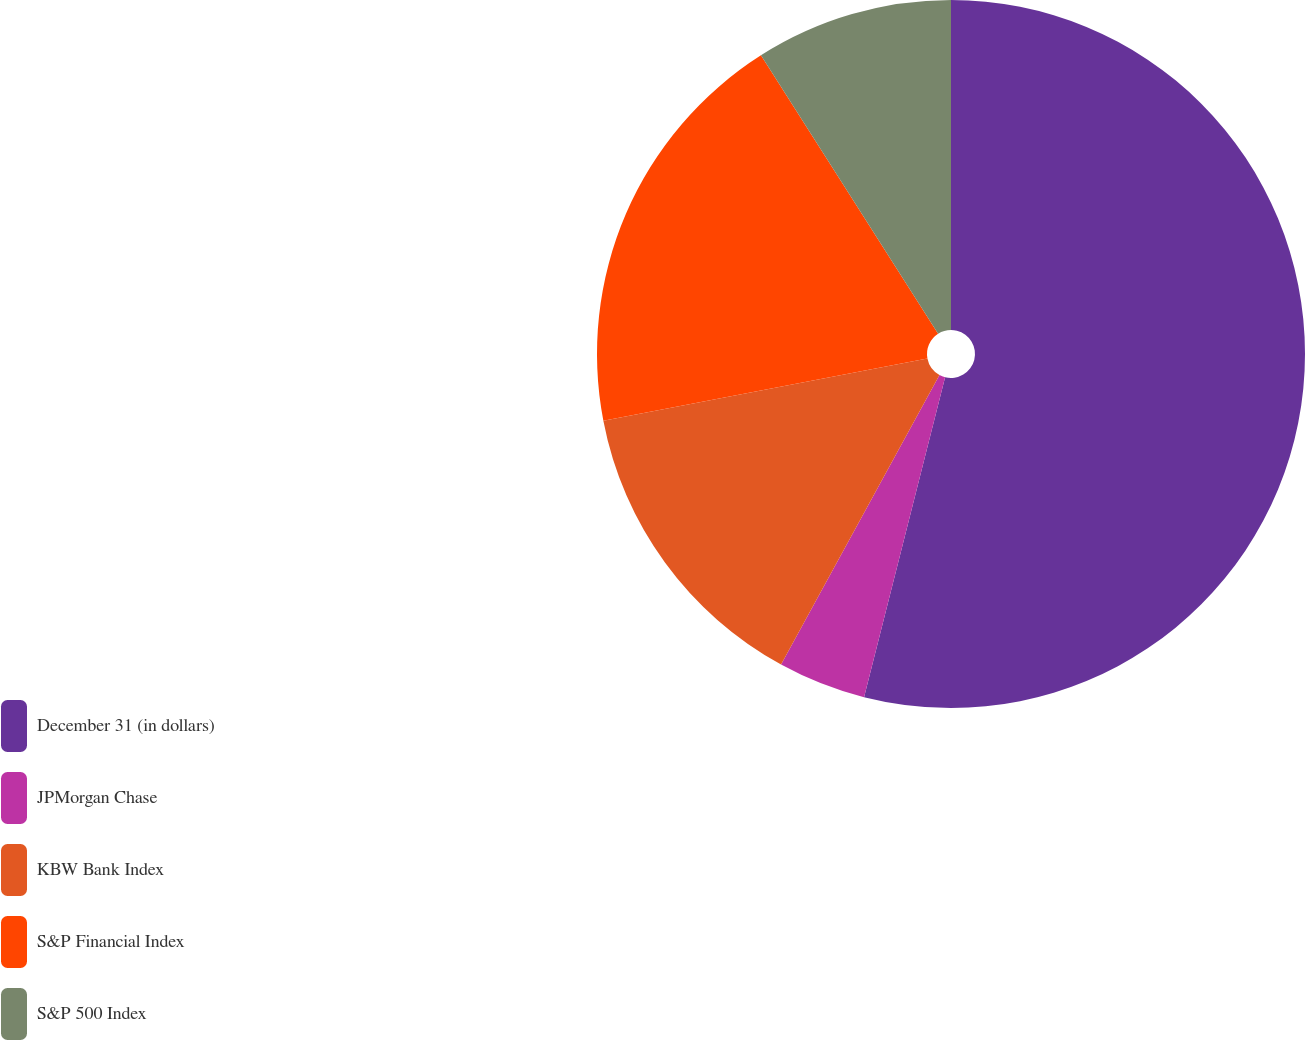Convert chart to OTSL. <chart><loc_0><loc_0><loc_500><loc_500><pie_chart><fcel>December 31 (in dollars)<fcel>JPMorgan Chase<fcel>KBW Bank Index<fcel>S&P Financial Index<fcel>S&P 500 Index<nl><fcel>53.95%<fcel>4.02%<fcel>14.01%<fcel>19.0%<fcel>9.02%<nl></chart> 